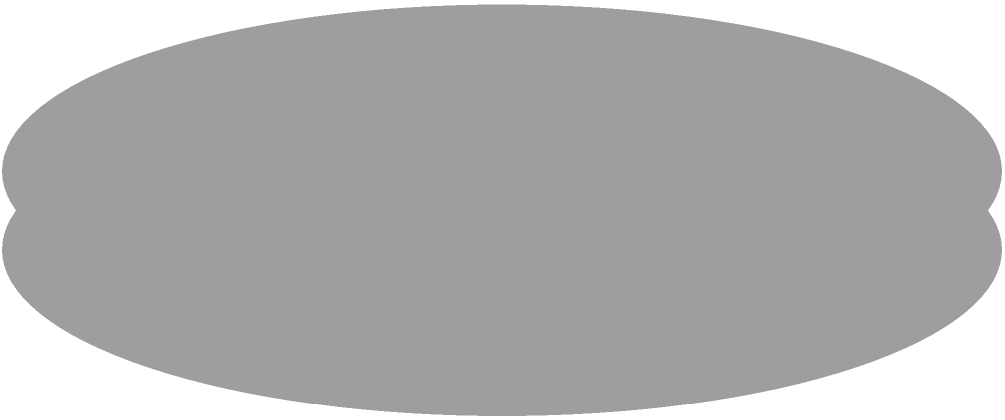As a fitness coach, you're designing a new weight plate for your client. The plate is shaped like a hollow cylinder with an outer radius of 12 cm, an inner radius of 10 cm, and a thickness of 2 cm. What is the total surface area of this weight plate in square centimeters? To calculate the total surface area of the hollow cylindrical weight plate, we need to consider three parts:

1. The outer circular faces (top and bottom):
   Area of outer circles = $2 \cdot \pi r_2^2 = 2 \cdot \pi \cdot 12^2 = 288\pi$ cm²

2. The inner circular faces (top and bottom):
   Area of inner circles = $2 \cdot \pi r_1^2 = 2 \cdot \pi \cdot 10^2 = 200\pi$ cm²

3. The outer and inner curved surfaces:
   Area of curved surfaces = $2\pi r_2 h + 2\pi r_1 h$
                           = $2\pi \cdot 12 \cdot 2 + 2\pi \cdot 10 \cdot 2$
                           = $48\pi + 40\pi = 88\pi$ cm²

Total surface area = Outer circles + Inner circles + Curved surfaces
                   = $288\pi + 200\pi + 88\pi$
                   = $576\pi$ cm²

Converting to a decimal:
$576\pi \approx 1809.56$ cm²
Answer: $576\pi$ cm² or approximately 1809.56 cm² 